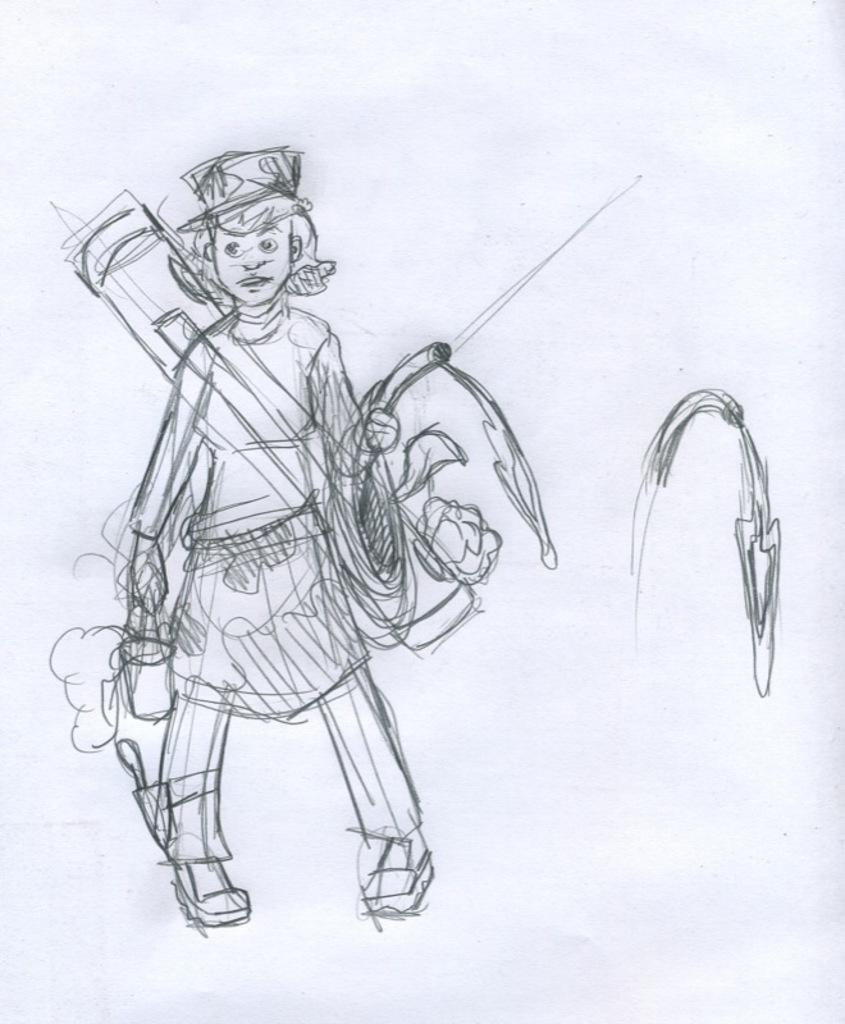What is the main subject of the image? There is a picture of a person in the image. What is the background color of the picture? The picture is drawn on a white color paper. Where is the picture located within the image? The picture is in the middle of the image. How many baby ducks are visible in the image? There are no baby ducks present in the image. What type of houses can be seen in the background of the image? There is no background or houses visible in the image, as it only features a picture of a person on a white color paper. 